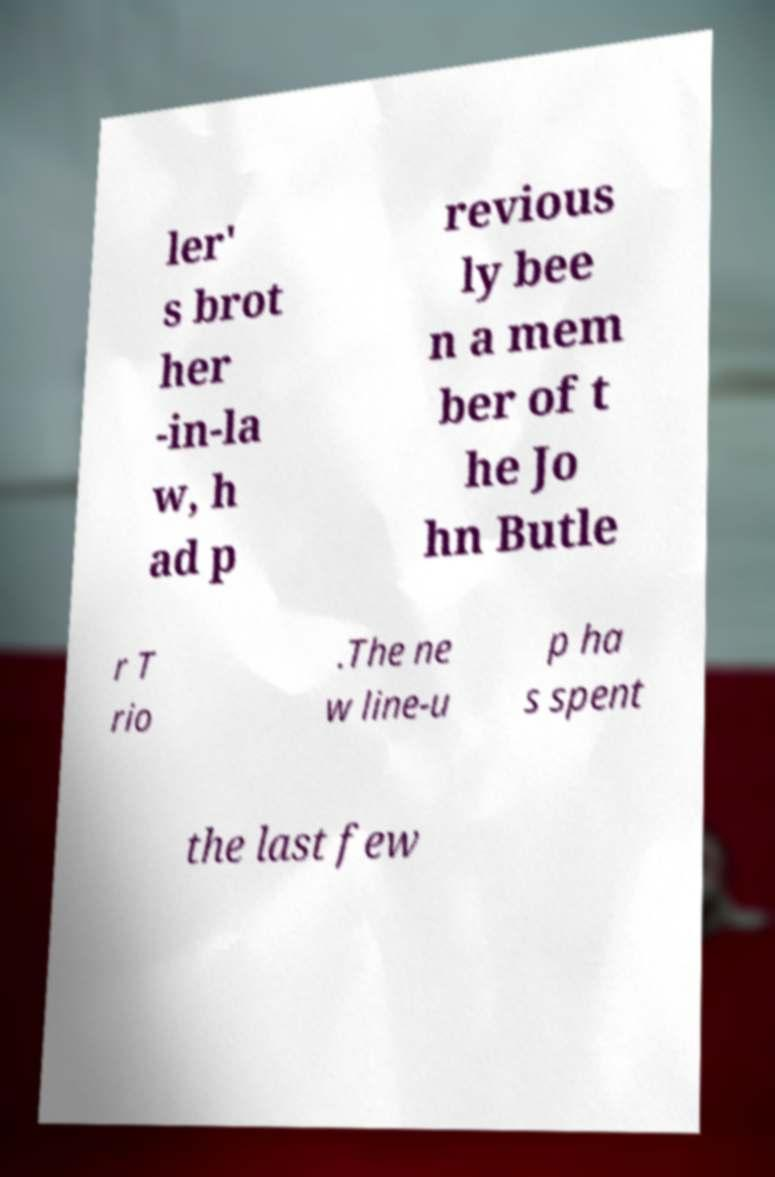What messages or text are displayed in this image? I need them in a readable, typed format. ler' s brot her -in-la w, h ad p revious ly bee n a mem ber of t he Jo hn Butle r T rio .The ne w line-u p ha s spent the last few 